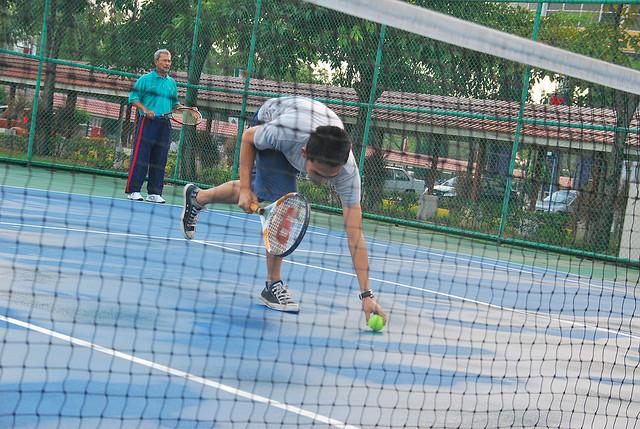Which company makes the green object here? wilson 